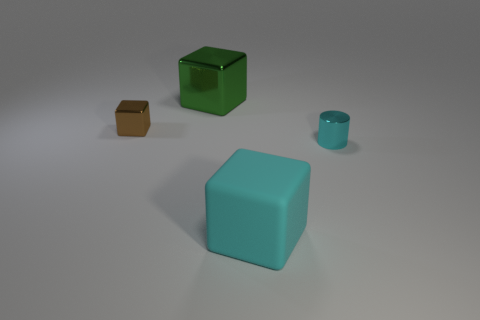Subtract all big blocks. How many blocks are left? 1 Subtract all cylinders. How many objects are left? 3 Subtract all green cubes. How many cubes are left? 2 Add 4 tiny brown things. How many objects exist? 8 Subtract all cyan cylinders. How many red cubes are left? 0 Subtract all tiny cyan rubber cylinders. Subtract all big matte cubes. How many objects are left? 3 Add 3 green blocks. How many green blocks are left? 4 Add 4 small purple cubes. How many small purple cubes exist? 4 Subtract 0 purple balls. How many objects are left? 4 Subtract 1 cubes. How many cubes are left? 2 